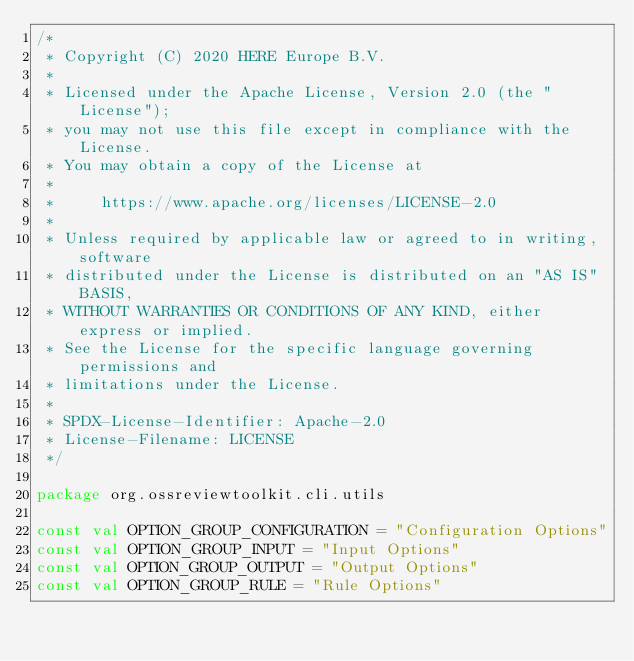Convert code to text. <code><loc_0><loc_0><loc_500><loc_500><_Kotlin_>/*
 * Copyright (C) 2020 HERE Europe B.V.
 *
 * Licensed under the Apache License, Version 2.0 (the "License");
 * you may not use this file except in compliance with the License.
 * You may obtain a copy of the License at
 *
 *     https://www.apache.org/licenses/LICENSE-2.0
 *
 * Unless required by applicable law or agreed to in writing, software
 * distributed under the License is distributed on an "AS IS" BASIS,
 * WITHOUT WARRANTIES OR CONDITIONS OF ANY KIND, either express or implied.
 * See the License for the specific language governing permissions and
 * limitations under the License.
 *
 * SPDX-License-Identifier: Apache-2.0
 * License-Filename: LICENSE
 */

package org.ossreviewtoolkit.cli.utils

const val OPTION_GROUP_CONFIGURATION = "Configuration Options"
const val OPTION_GROUP_INPUT = "Input Options"
const val OPTION_GROUP_OUTPUT = "Output Options"
const val OPTION_GROUP_RULE = "Rule Options"
</code> 